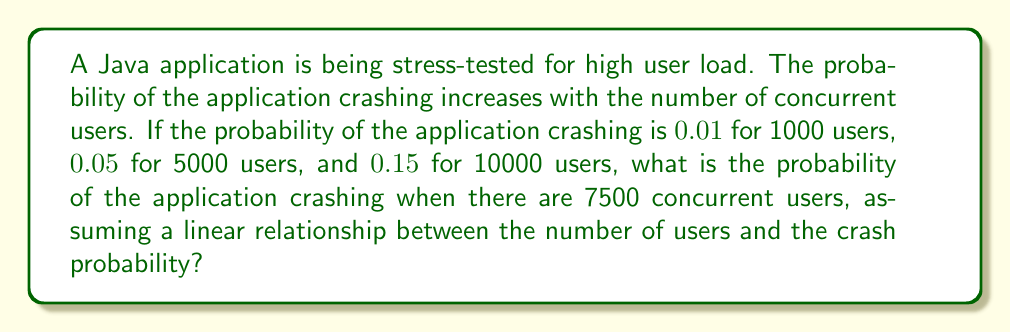Solve this math problem. Let's approach this step-by-step:

1) We're given three data points:
   - 1000 users: probability = 0.01
   - 5000 users: probability = 0.05
   - 10000 users: probability = 0.15

2) We need to find the linear relationship between the number of users (x) and the probability of crashing (y).

3) The general form of a linear equation is $y = mx + b$, where m is the slope and b is the y-intercept.

4) To find the slope (m), we can use any two points. Let's use 1000 and 10000 users:

   $m = \frac{y_2 - y_1}{x_2 - x_1} = \frac{0.15 - 0.01}{10000 - 1000} = \frac{0.14}{9000} = 0.0000155556$

5) Now we can use this slope and any point to find b. Let's use the 1000 users point:

   $0.01 = 0.0000155556 * 1000 + b$
   $b = 0.01 - 0.0155556 = -0.0055556$

6) So our linear equation is:
   $y = 0.0000155556x - 0.0055556$

7) For 7500 users, we plug in x = 7500:

   $y = 0.0000155556 * 7500 - 0.0055556 = 0.1111111$

Therefore, the probability of the application crashing with 7500 concurrent users is approximately 0.1111 or 11.11%.
Answer: 0.1111 